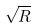<formula> <loc_0><loc_0><loc_500><loc_500>\sqrt { R }</formula> 